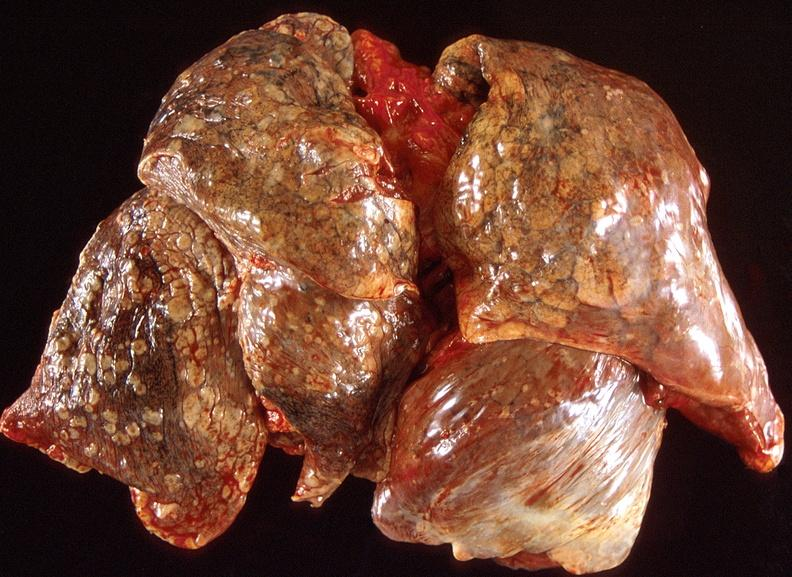does hypersegmented neutrophil show lung carcinoma?
Answer the question using a single word or phrase. No 